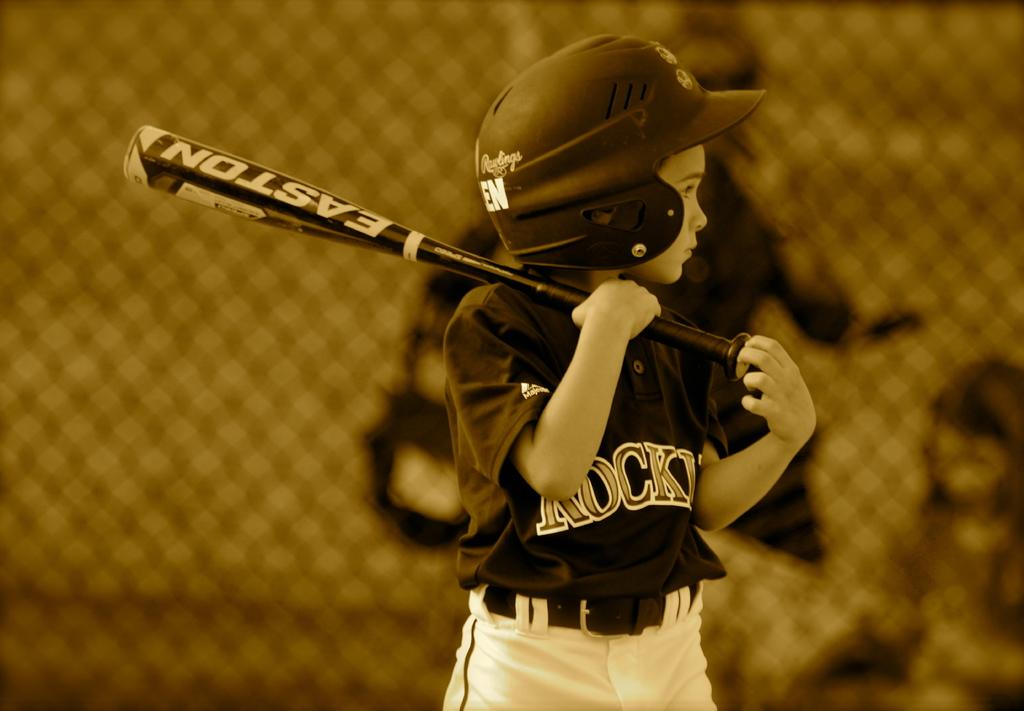What can be seen in the image? There is a person in the image. What is the person wearing on their head? The person is wearing a helmet. What type of clothing is the person wearing on their upper body? The person is wearing a t-shirt. What object is the person holding in the image? The person is holding a baseball bat. What is visible behind the person? There is a fencing behind the person. Can you hear the person talking in the image? There is no sound or audio in the image, so it is not possible to hear the person talking. 